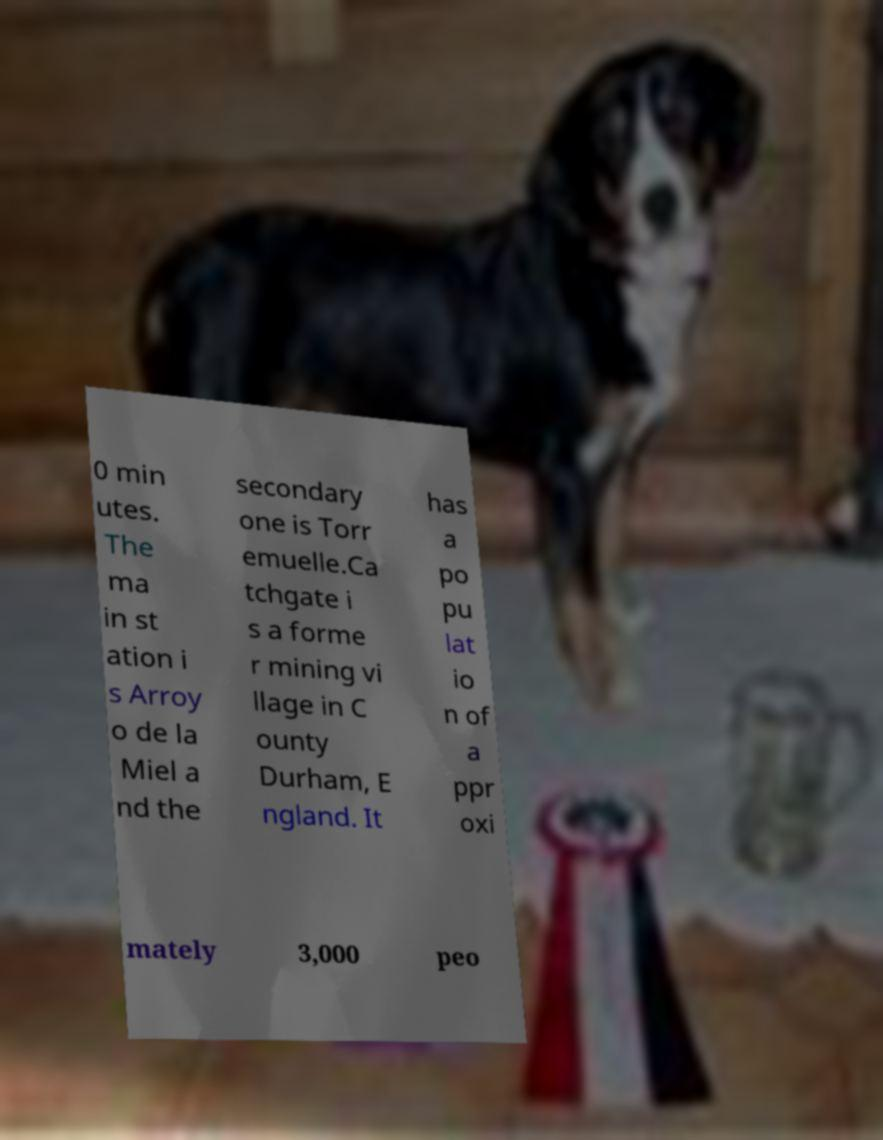For documentation purposes, I need the text within this image transcribed. Could you provide that? 0 min utes. The ma in st ation i s Arroy o de la Miel a nd the secondary one is Torr emuelle.Ca tchgate i s a forme r mining vi llage in C ounty Durham, E ngland. It has a po pu lat io n of a ppr oxi mately 3,000 peo 